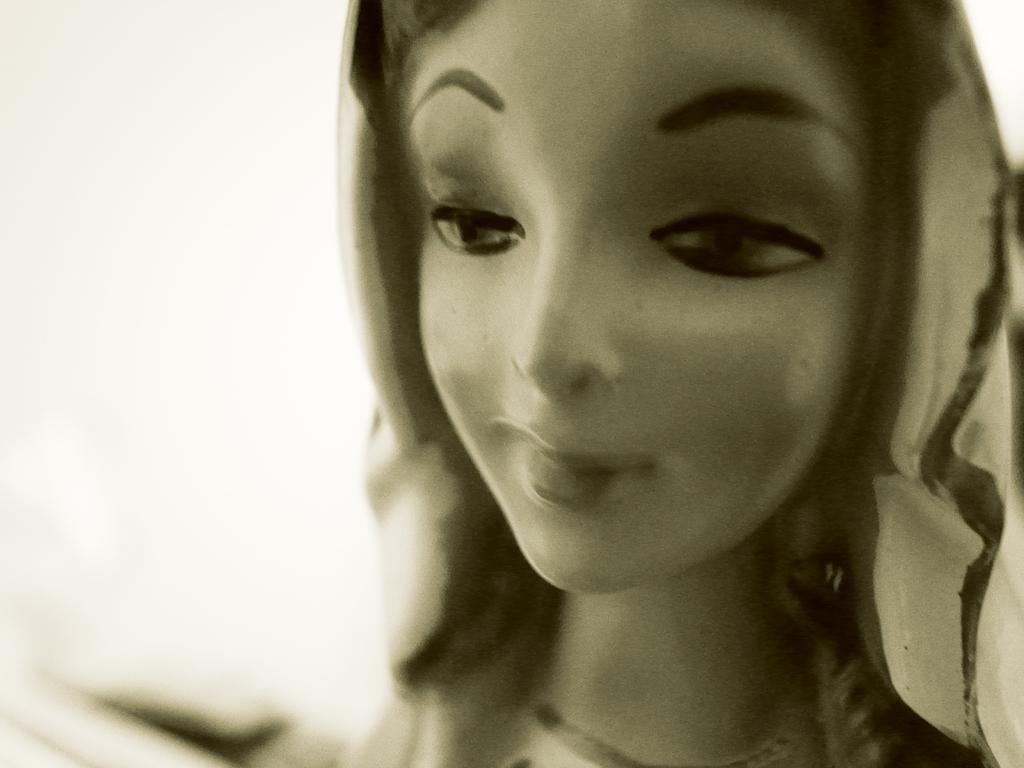What is the main subject in the image? There is a statue in the image. Can you describe the statue? The statue is of a lady. What type of payment is accepted by the lady statue in the image? The lady statue in the image does not accept any form of payment, as it is a non-living object. What type of drink is the lady statue holding in the image? The lady statue is not holding any drink in the image, as it is a non-living object. 